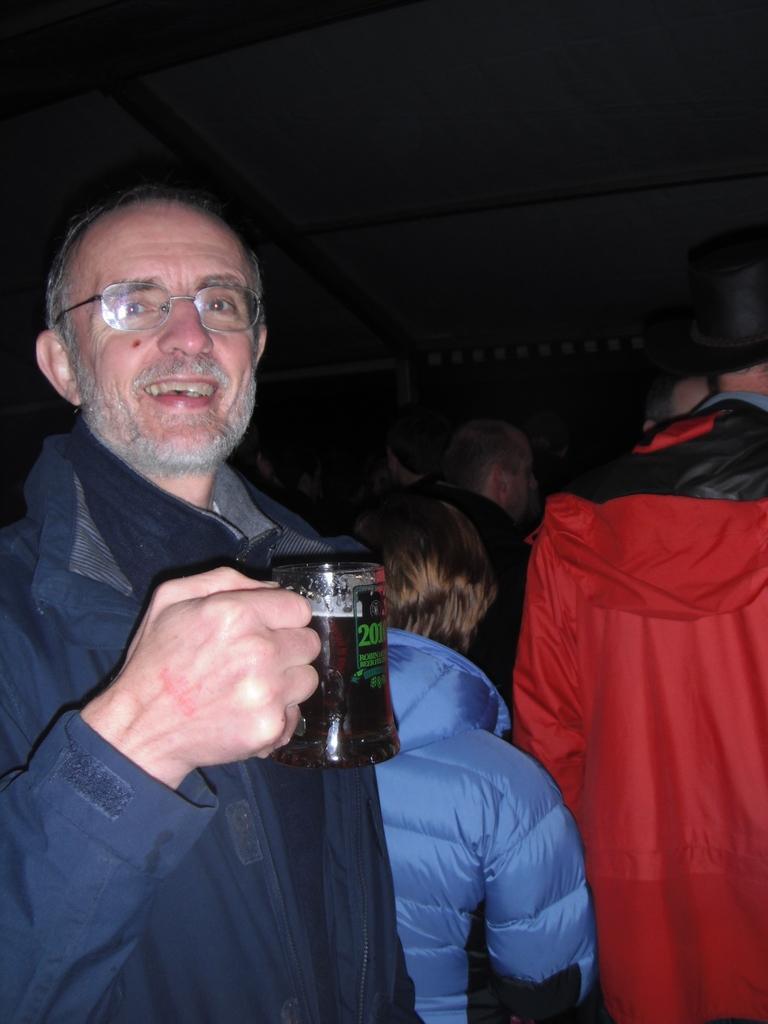How would you summarize this image in a sentence or two? In this image I can see the person smiling and holding the glass. To the left of him there are many people standing. 